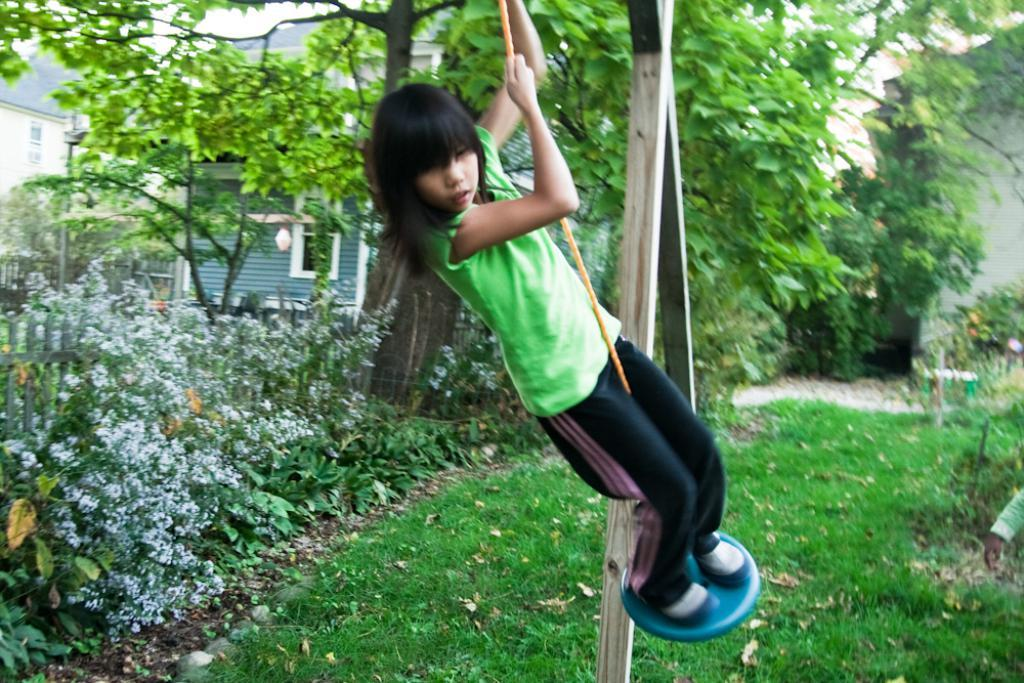Who is the main subject in the image? There is a girl in the image. What is the girl wearing? The girl is wearing a t-shirt. What is the girl doing in the image? The girl is standing and swinging. What type of surface is under the girl's feet? There is grass on the ground in the image. What can be seen in the background of the image? There are many plants, trees, and buildings in the background of the image. What type of stitch is the girl using to sew the can in the image? There is no can or stitching activity present in the image. What force is being applied by the girl to the can in the image? There is no can or force being applied in the image; the girl is standing and swinging. 